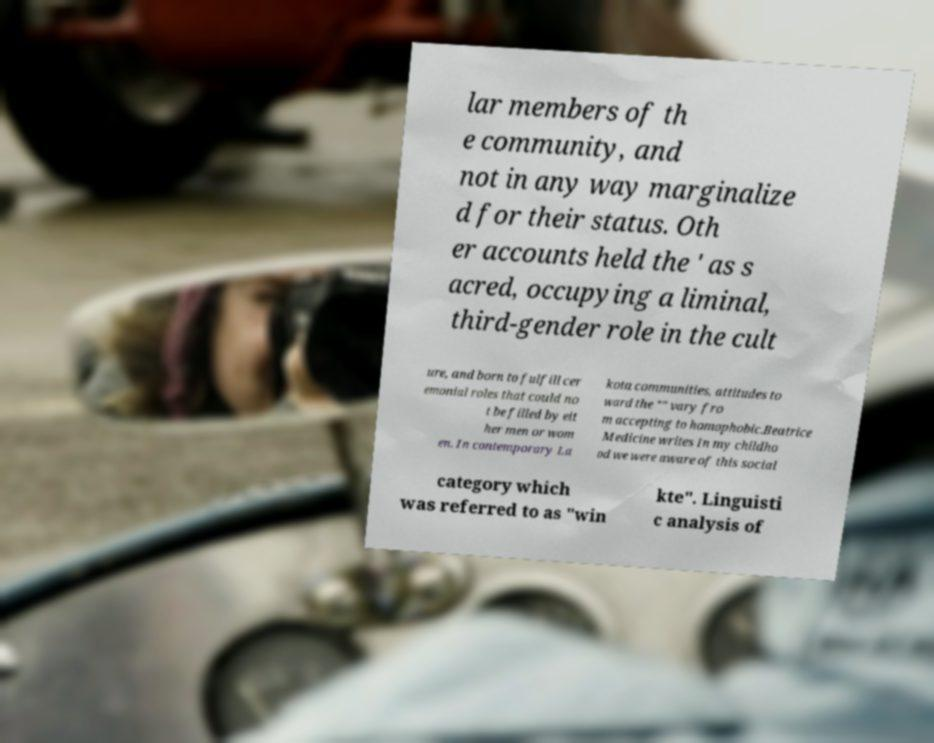Please identify and transcribe the text found in this image. lar members of th e community, and not in any way marginalize d for their status. Oth er accounts held the ' as s acred, occupying a liminal, third-gender role in the cult ure, and born to fulfill cer emonial roles that could no t be filled by eit her men or wom en. In contemporary La kota communities, attitudes to ward the "" vary fro m accepting to homophobic.Beatrice Medicine writes In my childho od we were aware of this social category which was referred to as "win kte". Linguisti c analysis of 